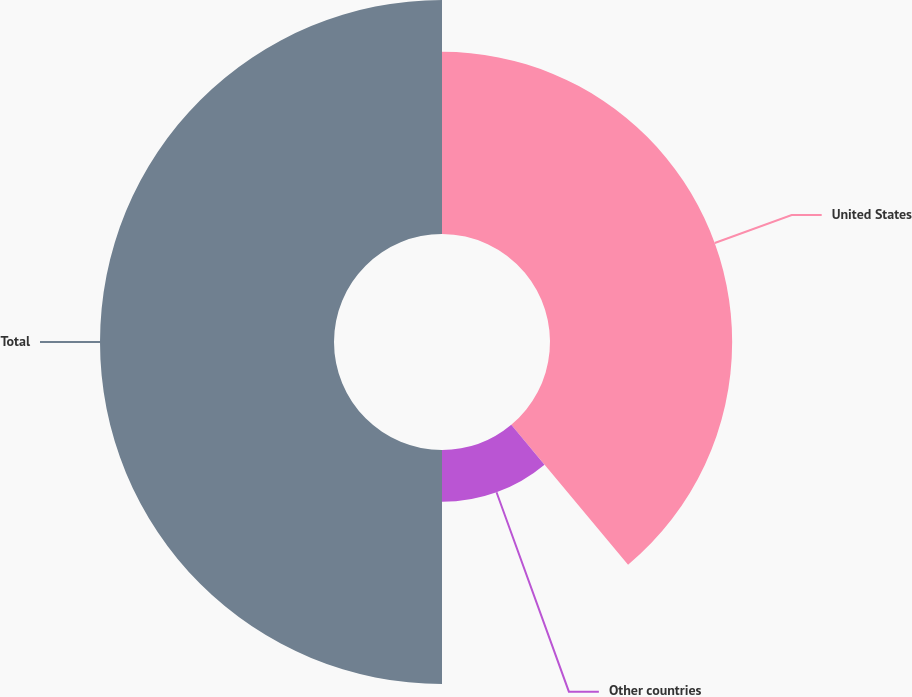Convert chart. <chart><loc_0><loc_0><loc_500><loc_500><pie_chart><fcel>United States<fcel>Other countries<fcel>Total<nl><fcel>38.92%<fcel>11.08%<fcel>50.0%<nl></chart> 